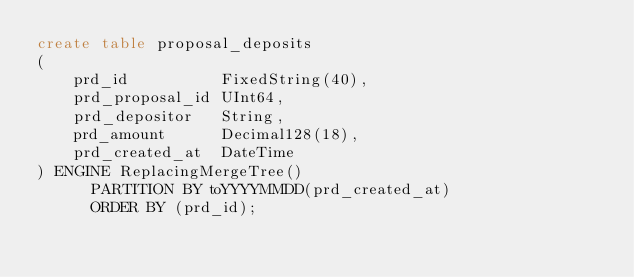<code> <loc_0><loc_0><loc_500><loc_500><_SQL_>create table proposal_deposits
(
    prd_id          FixedString(40),
    prd_proposal_id UInt64,
    prd_depositor   String,
    prd_amount      Decimal128(18),
    prd_created_at  DateTime
) ENGINE ReplacingMergeTree()
      PARTITION BY toYYYYMMDD(prd_created_at)
      ORDER BY (prd_id);

</code> 